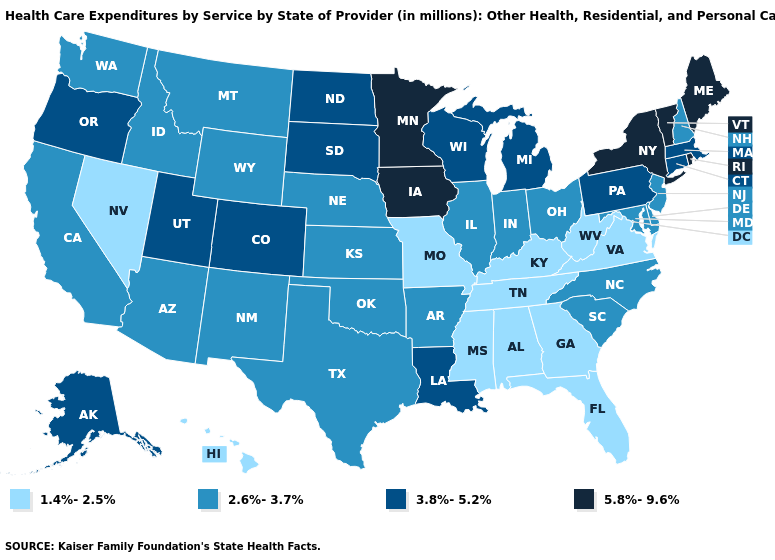Does Louisiana have a lower value than New York?
Concise answer only. Yes. What is the value of Texas?
Be succinct. 2.6%-3.7%. Among the states that border Indiana , does Kentucky have the lowest value?
Be succinct. Yes. Which states have the lowest value in the MidWest?
Answer briefly. Missouri. Does Oklahoma have the same value as New Mexico?
Write a very short answer. Yes. What is the highest value in the USA?
Short answer required. 5.8%-9.6%. Name the states that have a value in the range 3.8%-5.2%?
Be succinct. Alaska, Colorado, Connecticut, Louisiana, Massachusetts, Michigan, North Dakota, Oregon, Pennsylvania, South Dakota, Utah, Wisconsin. Among the states that border New York , does Pennsylvania have the lowest value?
Give a very brief answer. No. What is the value of North Carolina?
Answer briefly. 2.6%-3.7%. Name the states that have a value in the range 5.8%-9.6%?
Keep it brief. Iowa, Maine, Minnesota, New York, Rhode Island, Vermont. What is the value of Arkansas?
Concise answer only. 2.6%-3.7%. What is the value of Kansas?
Keep it brief. 2.6%-3.7%. What is the lowest value in states that border Ohio?
Concise answer only. 1.4%-2.5%. Name the states that have a value in the range 2.6%-3.7%?
Answer briefly. Arizona, Arkansas, California, Delaware, Idaho, Illinois, Indiana, Kansas, Maryland, Montana, Nebraska, New Hampshire, New Jersey, New Mexico, North Carolina, Ohio, Oklahoma, South Carolina, Texas, Washington, Wyoming. Name the states that have a value in the range 2.6%-3.7%?
Short answer required. Arizona, Arkansas, California, Delaware, Idaho, Illinois, Indiana, Kansas, Maryland, Montana, Nebraska, New Hampshire, New Jersey, New Mexico, North Carolina, Ohio, Oklahoma, South Carolina, Texas, Washington, Wyoming. 